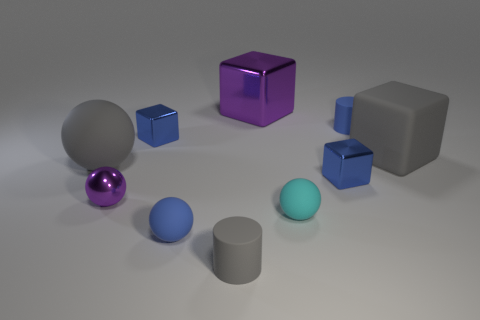Can you talk about the textures visible in the image? Certainly. The spherical objects exhibit smooth textures, reflecting light and denoting a glossy material. The cube and the rectangular prism share a more complex and reflective texture, suggesting a metallic or plastic surface, while the cylinders appear to have a matte finish. 